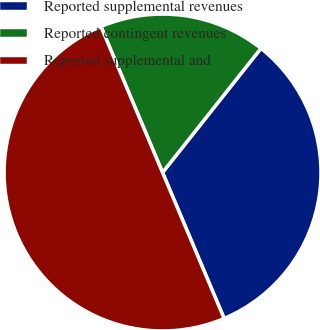Convert chart. <chart><loc_0><loc_0><loc_500><loc_500><pie_chart><fcel>Reported supplemental revenues<fcel>Reported contingent revenues<fcel>Reported supplemental and<nl><fcel>32.98%<fcel>17.02%<fcel>50.0%<nl></chart> 